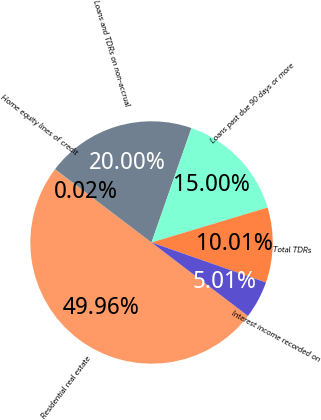Convert chart to OTSL. <chart><loc_0><loc_0><loc_500><loc_500><pie_chart><fcel>Residential real estate<fcel>Home equity lines of credit<fcel>Loans and TDRs on non-accrual<fcel>Loans past due 90 days or more<fcel>Total TDRs<fcel>Interest income recorded on<nl><fcel>49.96%<fcel>0.02%<fcel>20.0%<fcel>15.0%<fcel>10.01%<fcel>5.01%<nl></chart> 